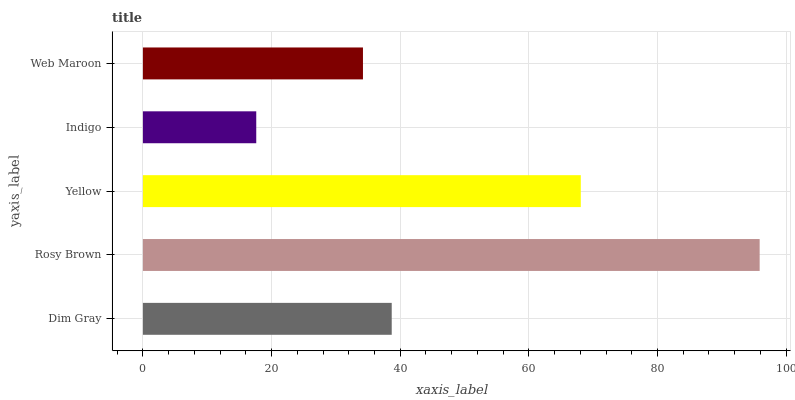Is Indigo the minimum?
Answer yes or no. Yes. Is Rosy Brown the maximum?
Answer yes or no. Yes. Is Yellow the minimum?
Answer yes or no. No. Is Yellow the maximum?
Answer yes or no. No. Is Rosy Brown greater than Yellow?
Answer yes or no. Yes. Is Yellow less than Rosy Brown?
Answer yes or no. Yes. Is Yellow greater than Rosy Brown?
Answer yes or no. No. Is Rosy Brown less than Yellow?
Answer yes or no. No. Is Dim Gray the high median?
Answer yes or no. Yes. Is Dim Gray the low median?
Answer yes or no. Yes. Is Web Maroon the high median?
Answer yes or no. No. Is Web Maroon the low median?
Answer yes or no. No. 